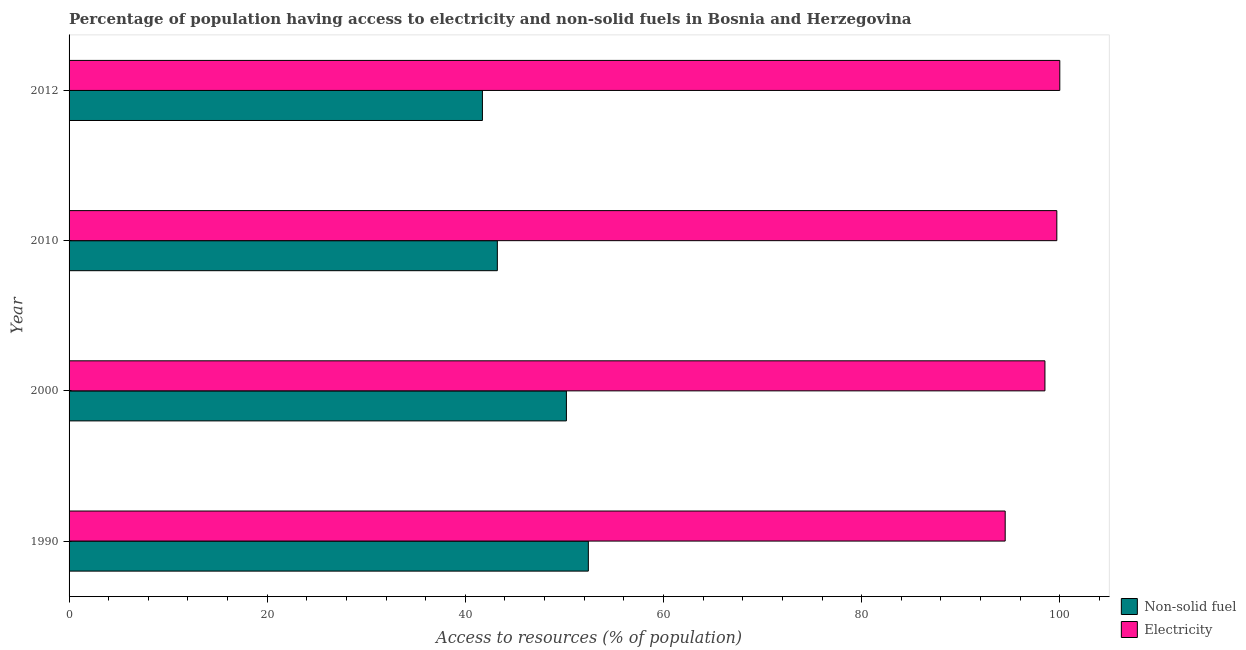How many groups of bars are there?
Give a very brief answer. 4. How many bars are there on the 2nd tick from the top?
Make the answer very short. 2. What is the label of the 3rd group of bars from the top?
Provide a succinct answer. 2000. What is the percentage of population having access to electricity in 2012?
Offer a terse response. 100. Across all years, what is the maximum percentage of population having access to non-solid fuel?
Make the answer very short. 52.41. Across all years, what is the minimum percentage of population having access to electricity?
Provide a short and direct response. 94.49. In which year was the percentage of population having access to electricity maximum?
Ensure brevity in your answer.  2012. In which year was the percentage of population having access to non-solid fuel minimum?
Keep it short and to the point. 2012. What is the total percentage of population having access to non-solid fuel in the graph?
Provide a succinct answer. 187.56. What is the difference between the percentage of population having access to electricity in 1990 and that in 2000?
Keep it short and to the point. -4.01. What is the difference between the percentage of population having access to non-solid fuel in 2000 and the percentage of population having access to electricity in 2012?
Make the answer very short. -49.8. What is the average percentage of population having access to non-solid fuel per year?
Offer a terse response. 46.89. In the year 2010, what is the difference between the percentage of population having access to non-solid fuel and percentage of population having access to electricity?
Offer a terse response. -56.47. What is the ratio of the percentage of population having access to non-solid fuel in 2000 to that in 2012?
Offer a terse response. 1.2. What is the difference between the highest and the second highest percentage of population having access to non-solid fuel?
Ensure brevity in your answer.  2.21. What is the difference between the highest and the lowest percentage of population having access to electricity?
Provide a short and direct response. 5.51. In how many years, is the percentage of population having access to electricity greater than the average percentage of population having access to electricity taken over all years?
Offer a terse response. 3. Is the sum of the percentage of population having access to electricity in 1990 and 2000 greater than the maximum percentage of population having access to non-solid fuel across all years?
Provide a short and direct response. Yes. What does the 2nd bar from the top in 1990 represents?
Offer a very short reply. Non-solid fuel. What does the 2nd bar from the bottom in 2000 represents?
Your answer should be compact. Electricity. How many bars are there?
Provide a short and direct response. 8. Are the values on the major ticks of X-axis written in scientific E-notation?
Your answer should be very brief. No. Where does the legend appear in the graph?
Provide a short and direct response. Bottom right. How are the legend labels stacked?
Provide a short and direct response. Vertical. What is the title of the graph?
Your response must be concise. Percentage of population having access to electricity and non-solid fuels in Bosnia and Herzegovina. Does "Male labor force" appear as one of the legend labels in the graph?
Offer a very short reply. No. What is the label or title of the X-axis?
Your answer should be very brief. Access to resources (% of population). What is the label or title of the Y-axis?
Your response must be concise. Year. What is the Access to resources (% of population) in Non-solid fuel in 1990?
Offer a very short reply. 52.41. What is the Access to resources (% of population) in Electricity in 1990?
Offer a very short reply. 94.49. What is the Access to resources (% of population) of Non-solid fuel in 2000?
Give a very brief answer. 50.2. What is the Access to resources (% of population) in Electricity in 2000?
Give a very brief answer. 98.5. What is the Access to resources (% of population) of Non-solid fuel in 2010?
Provide a succinct answer. 43.23. What is the Access to resources (% of population) of Electricity in 2010?
Your response must be concise. 99.7. What is the Access to resources (% of population) of Non-solid fuel in 2012?
Give a very brief answer. 41.72. What is the Access to resources (% of population) of Electricity in 2012?
Ensure brevity in your answer.  100. Across all years, what is the maximum Access to resources (% of population) of Non-solid fuel?
Your answer should be compact. 52.41. Across all years, what is the maximum Access to resources (% of population) of Electricity?
Provide a short and direct response. 100. Across all years, what is the minimum Access to resources (% of population) in Non-solid fuel?
Provide a succinct answer. 41.72. Across all years, what is the minimum Access to resources (% of population) of Electricity?
Ensure brevity in your answer.  94.49. What is the total Access to resources (% of population) in Non-solid fuel in the graph?
Give a very brief answer. 187.56. What is the total Access to resources (% of population) in Electricity in the graph?
Provide a short and direct response. 392.69. What is the difference between the Access to resources (% of population) in Non-solid fuel in 1990 and that in 2000?
Provide a short and direct response. 2.22. What is the difference between the Access to resources (% of population) in Electricity in 1990 and that in 2000?
Offer a very short reply. -4.01. What is the difference between the Access to resources (% of population) in Non-solid fuel in 1990 and that in 2010?
Ensure brevity in your answer.  9.19. What is the difference between the Access to resources (% of population) in Electricity in 1990 and that in 2010?
Your answer should be very brief. -5.21. What is the difference between the Access to resources (% of population) of Non-solid fuel in 1990 and that in 2012?
Provide a succinct answer. 10.69. What is the difference between the Access to resources (% of population) in Electricity in 1990 and that in 2012?
Keep it short and to the point. -5.51. What is the difference between the Access to resources (% of population) of Non-solid fuel in 2000 and that in 2010?
Offer a terse response. 6.97. What is the difference between the Access to resources (% of population) in Non-solid fuel in 2000 and that in 2012?
Give a very brief answer. 8.48. What is the difference between the Access to resources (% of population) of Non-solid fuel in 2010 and that in 2012?
Your response must be concise. 1.51. What is the difference between the Access to resources (% of population) in Electricity in 2010 and that in 2012?
Your answer should be compact. -0.3. What is the difference between the Access to resources (% of population) in Non-solid fuel in 1990 and the Access to resources (% of population) in Electricity in 2000?
Provide a short and direct response. -46.09. What is the difference between the Access to resources (% of population) of Non-solid fuel in 1990 and the Access to resources (% of population) of Electricity in 2010?
Make the answer very short. -47.29. What is the difference between the Access to resources (% of population) of Non-solid fuel in 1990 and the Access to resources (% of population) of Electricity in 2012?
Provide a short and direct response. -47.59. What is the difference between the Access to resources (% of population) in Non-solid fuel in 2000 and the Access to resources (% of population) in Electricity in 2010?
Offer a terse response. -49.5. What is the difference between the Access to resources (% of population) in Non-solid fuel in 2000 and the Access to resources (% of population) in Electricity in 2012?
Your response must be concise. -49.8. What is the difference between the Access to resources (% of population) in Non-solid fuel in 2010 and the Access to resources (% of population) in Electricity in 2012?
Give a very brief answer. -56.77. What is the average Access to resources (% of population) in Non-solid fuel per year?
Offer a very short reply. 46.89. What is the average Access to resources (% of population) in Electricity per year?
Keep it short and to the point. 98.17. In the year 1990, what is the difference between the Access to resources (% of population) in Non-solid fuel and Access to resources (% of population) in Electricity?
Ensure brevity in your answer.  -42.07. In the year 2000, what is the difference between the Access to resources (% of population) in Non-solid fuel and Access to resources (% of population) in Electricity?
Keep it short and to the point. -48.3. In the year 2010, what is the difference between the Access to resources (% of population) in Non-solid fuel and Access to resources (% of population) in Electricity?
Provide a short and direct response. -56.47. In the year 2012, what is the difference between the Access to resources (% of population) of Non-solid fuel and Access to resources (% of population) of Electricity?
Provide a short and direct response. -58.28. What is the ratio of the Access to resources (% of population) in Non-solid fuel in 1990 to that in 2000?
Your response must be concise. 1.04. What is the ratio of the Access to resources (% of population) of Electricity in 1990 to that in 2000?
Provide a short and direct response. 0.96. What is the ratio of the Access to resources (% of population) of Non-solid fuel in 1990 to that in 2010?
Ensure brevity in your answer.  1.21. What is the ratio of the Access to resources (% of population) in Electricity in 1990 to that in 2010?
Keep it short and to the point. 0.95. What is the ratio of the Access to resources (% of population) of Non-solid fuel in 1990 to that in 2012?
Make the answer very short. 1.26. What is the ratio of the Access to resources (% of population) of Electricity in 1990 to that in 2012?
Offer a terse response. 0.94. What is the ratio of the Access to resources (% of population) in Non-solid fuel in 2000 to that in 2010?
Your response must be concise. 1.16. What is the ratio of the Access to resources (% of population) of Non-solid fuel in 2000 to that in 2012?
Provide a short and direct response. 1.2. What is the ratio of the Access to resources (% of population) of Non-solid fuel in 2010 to that in 2012?
Your answer should be compact. 1.04. What is the ratio of the Access to resources (% of population) of Electricity in 2010 to that in 2012?
Your answer should be compact. 1. What is the difference between the highest and the second highest Access to resources (% of population) in Non-solid fuel?
Provide a short and direct response. 2.22. What is the difference between the highest and the second highest Access to resources (% of population) in Electricity?
Offer a terse response. 0.3. What is the difference between the highest and the lowest Access to resources (% of population) of Non-solid fuel?
Offer a terse response. 10.69. What is the difference between the highest and the lowest Access to resources (% of population) of Electricity?
Make the answer very short. 5.51. 